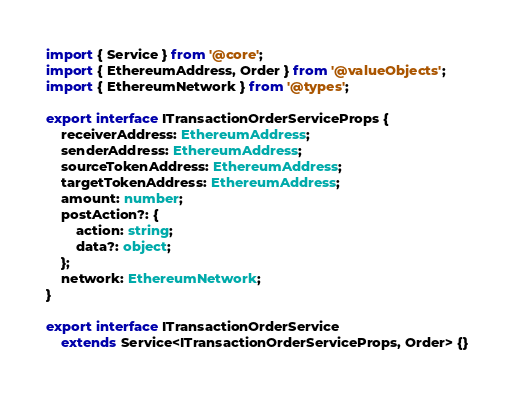<code> <loc_0><loc_0><loc_500><loc_500><_TypeScript_>import { Service } from '@core';
import { EthereumAddress, Order } from '@valueObjects';
import { EthereumNetwork } from '@types';

export interface ITransactionOrderServiceProps {
    receiverAddress: EthereumAddress;
    senderAddress: EthereumAddress;
    sourceTokenAddress: EthereumAddress;
    targetTokenAddress: EthereumAddress;
    amount: number;
    postAction?: {
        action: string;
        data?: object;
    };
    network: EthereumNetwork;
}

export interface ITransactionOrderService
    extends Service<ITransactionOrderServiceProps, Order> {}
</code> 